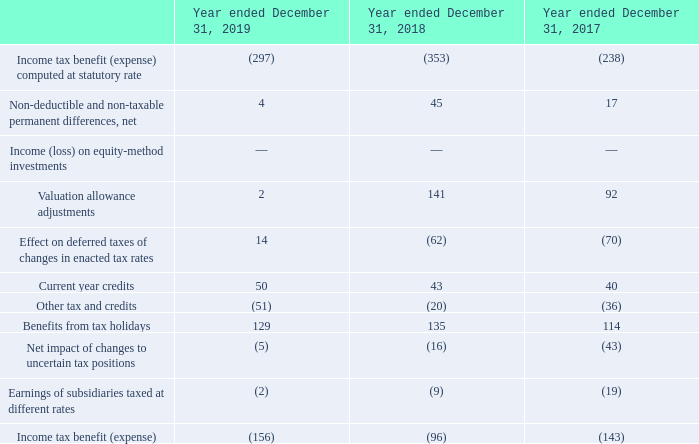The tax holidays represent a tax exemption period aimed to attract foreign technological investment in certain tax jurisdictions. The effect of the tax benefits, from tax holidays for countries which are profitable, on basic earnings per share was $0.14, $0.15 and $0.13 for the years ended December 31, 2019, 2018, and 2017, respectively. These agreements are present in various countries and include programs that reduce up to and including 100% of taxes in years affected by the agreements.
The Company’s tax holidays expire at various dates through the year ending December 31, 2028. In certain countries, tax holidays can be renewed depending on the Company still meeting certain conditions at the date of expiration of the current tax holidays.
In May 2019, Switzerland voted a tax reform which cancelled all favourable tax regimes and introduced a single tax rate for all companies, which triggered the revaluation of all deferred tax assets and liabilities. Enactment of this law occurred in third quarter of 2019, which resulted in a tax benefit of $20 million. The remeasurement of deferred taxes was reconciled in the fourth quarter of 2019 to include the current year activity, which did not have a material impact on the net remeasurement.
What is tax holidays? The tax holidays represent a tax exemption period aimed to attract foreign technological investment in certain tax jurisdictions. What was the effect of tax holidays on the basic earnings per share in 2019? $0.14. What was the tax benefit of the enactment of the tax reform introduced by Switzerland in third quarter 2019? $20 million. What is the increase/ (decrease) in Income tax benefit (expense) computed at statutory rate from December 31, 2018 to 2019?
Answer scale should be: million. 297-353
Answer: -56. What is the increase/ (decrease) in Benefits from tax holidays from December 31, 2018 to 2019?
Answer scale should be: million. 129-135
Answer: -6. What is the increase/ (decrease) in Income tax benefit (expense) from December 31, 2018 to 2019?
Answer scale should be: million. 156-96
Answer: 60. 